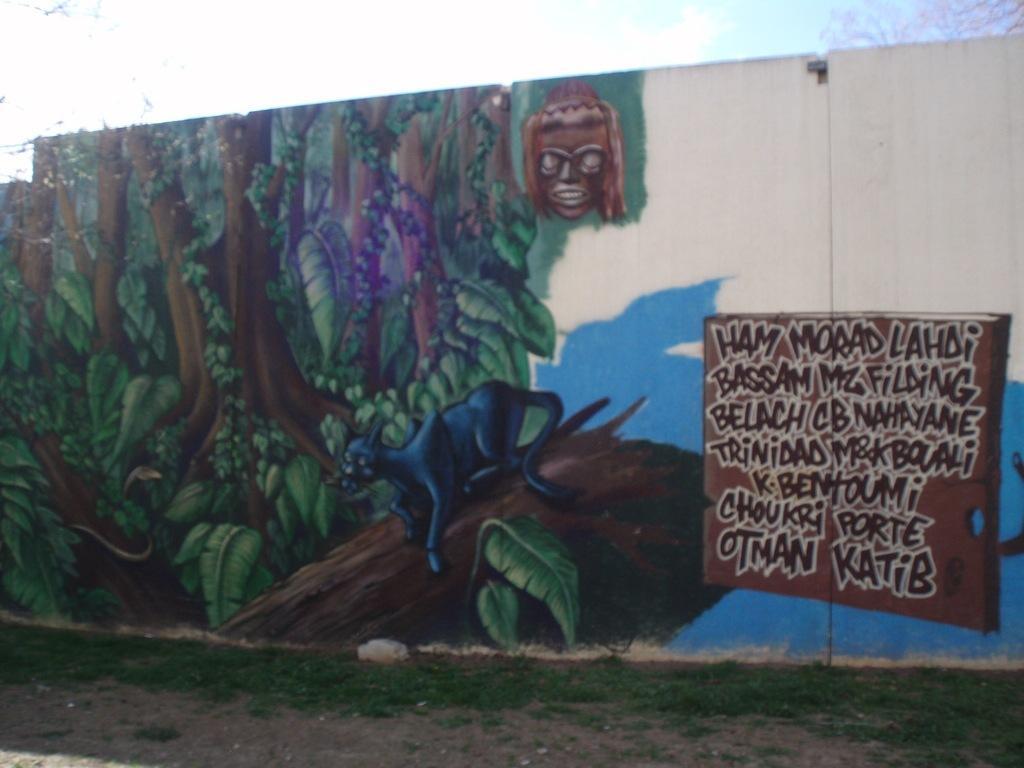How would you summarize this image in a sentence or two? A painting is made on a wall. 